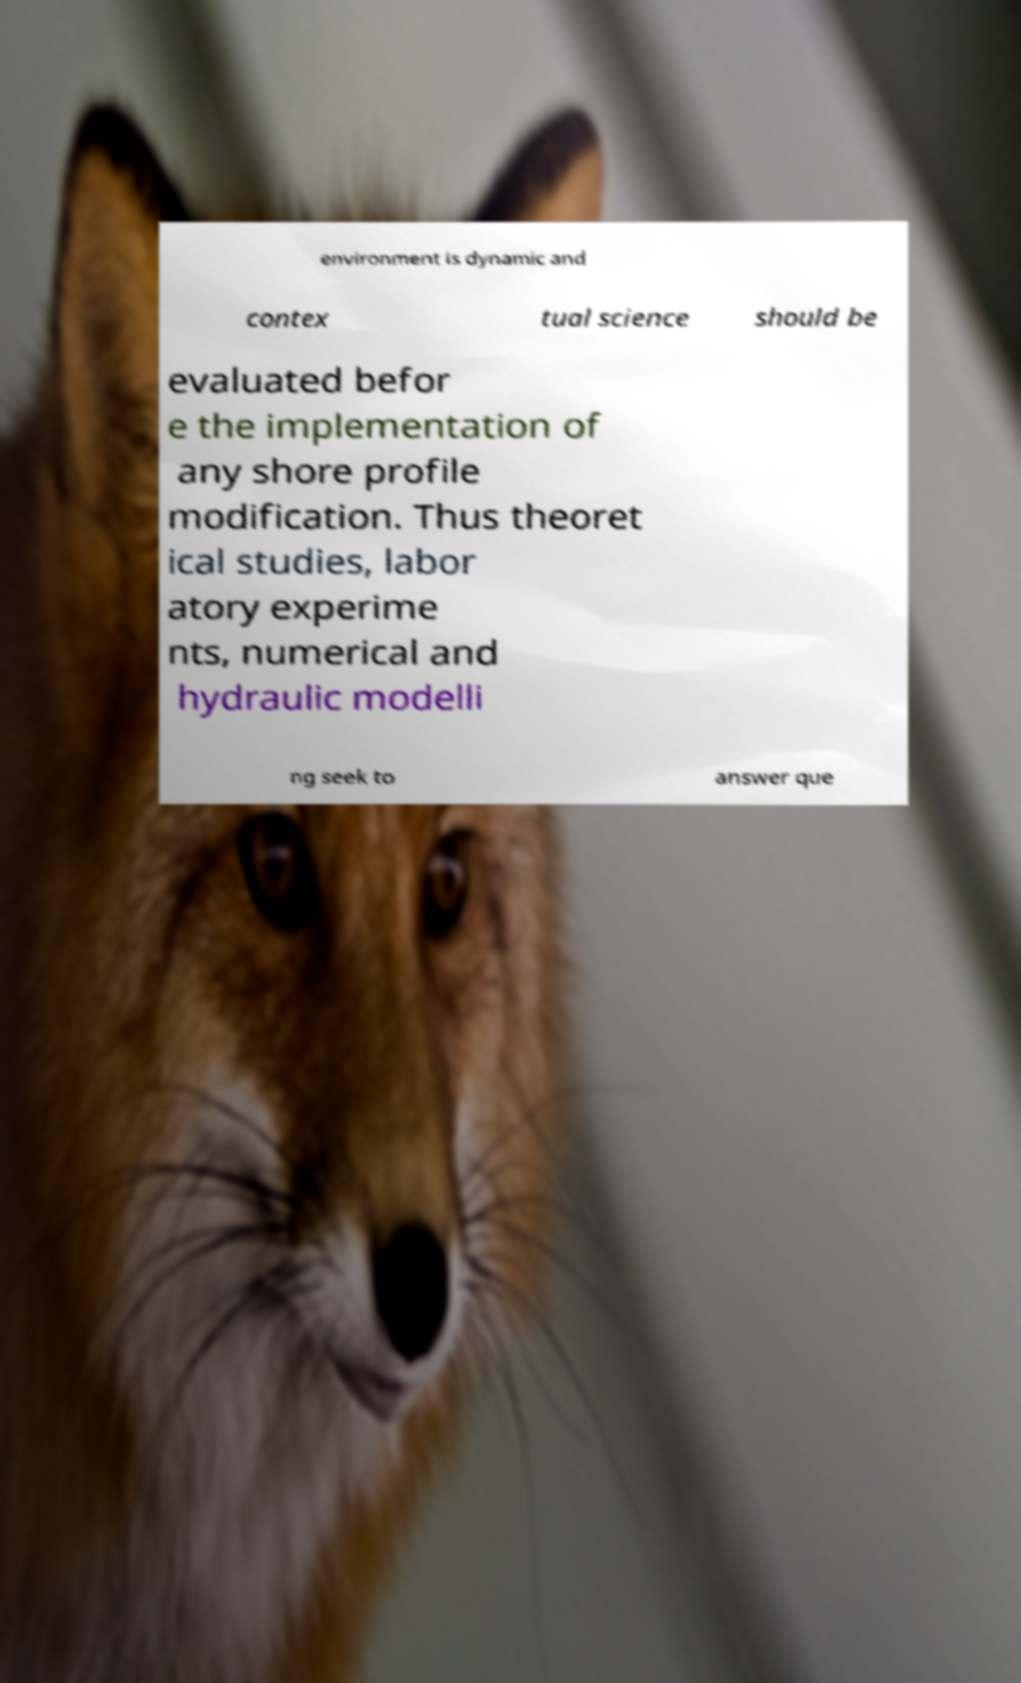What messages or text are displayed in this image? I need them in a readable, typed format. environment is dynamic and contex tual science should be evaluated befor e the implementation of any shore profile modification. Thus theoret ical studies, labor atory experime nts, numerical and hydraulic modelli ng seek to answer que 